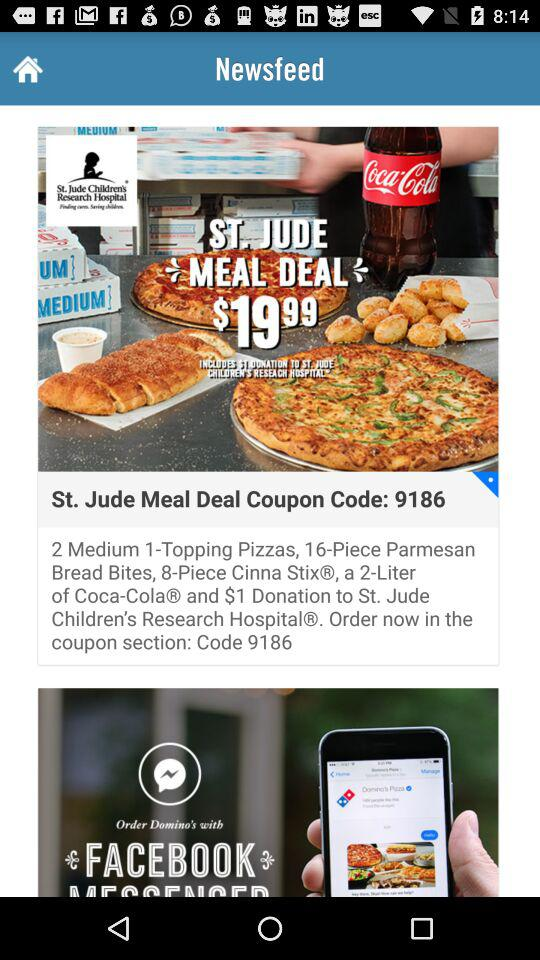What size is mentioned for the pizza? The mentioned size for the pizza is medium. 